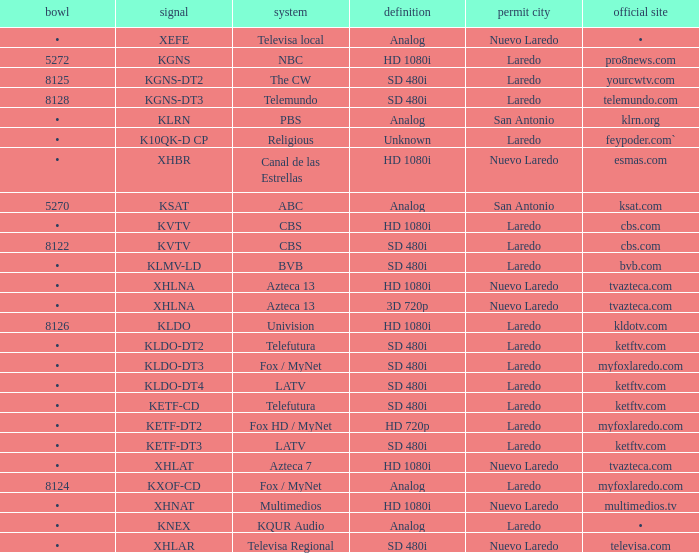Name the dish for resolution of sd 480i and network of bvb •. 